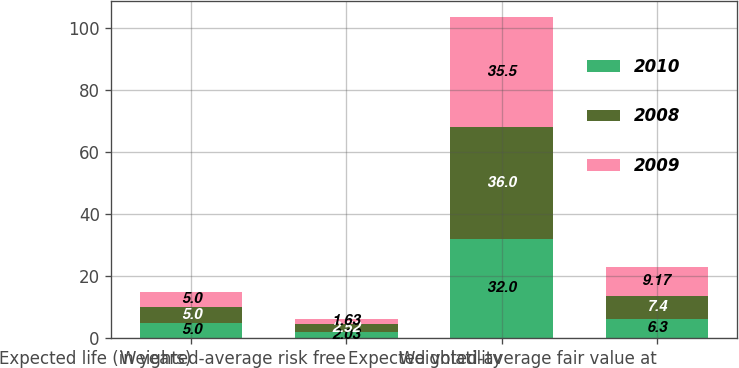<chart> <loc_0><loc_0><loc_500><loc_500><stacked_bar_chart><ecel><fcel>Expected life (in years)<fcel>Weighted-average risk free<fcel>Expected volatility<fcel>Weighted-average fair value at<nl><fcel>2010<fcel>5<fcel>2.03<fcel>32<fcel>6.3<nl><fcel>2008<fcel>5<fcel>2.52<fcel>36<fcel>7.4<nl><fcel>2009<fcel>5<fcel>1.63<fcel>35.5<fcel>9.17<nl></chart> 